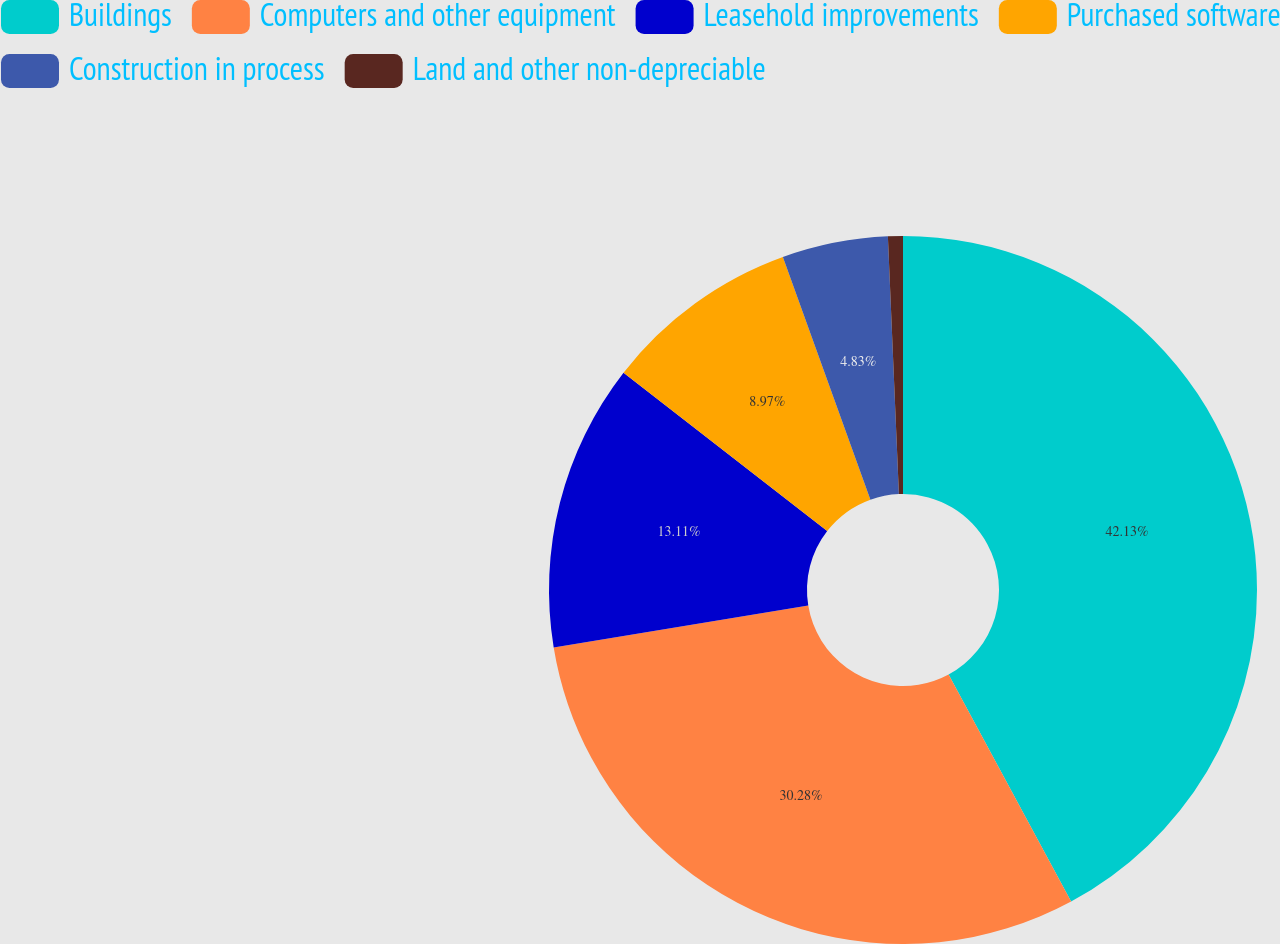<chart> <loc_0><loc_0><loc_500><loc_500><pie_chart><fcel>Buildings<fcel>Computers and other equipment<fcel>Leasehold improvements<fcel>Purchased software<fcel>Construction in process<fcel>Land and other non-depreciable<nl><fcel>42.12%<fcel>30.28%<fcel>13.11%<fcel>8.97%<fcel>4.83%<fcel>0.68%<nl></chart> 